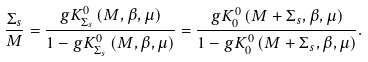<formula> <loc_0><loc_0><loc_500><loc_500>\frac { \Sigma _ { s } } { M } = \frac { g K _ { \Sigma _ { s } } ^ { 0 } \left ( M , \beta , \mu \right ) } { 1 - g K _ { \Sigma _ { s } } ^ { 0 } \left ( M , \beta , \mu \right ) } = \frac { g K _ { 0 } ^ { 0 } \left ( M + \Sigma _ { s } , \beta , \mu \right ) } { 1 - g K _ { 0 } ^ { 0 } \left ( M + \Sigma _ { s } , \beta , \mu \right ) } .</formula> 